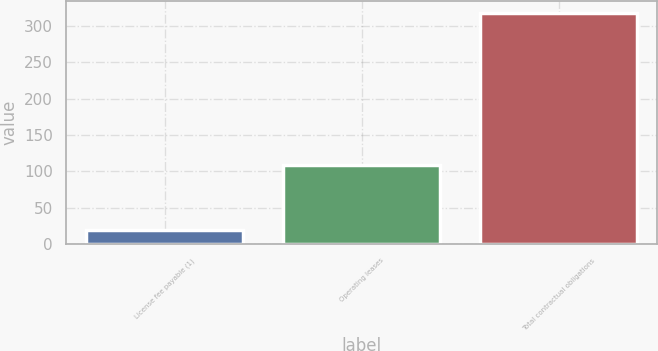<chart> <loc_0><loc_0><loc_500><loc_500><bar_chart><fcel>License fee payable (1)<fcel>Operating leases<fcel>Total contractual obligations<nl><fcel>20<fcel>109<fcel>318<nl></chart> 